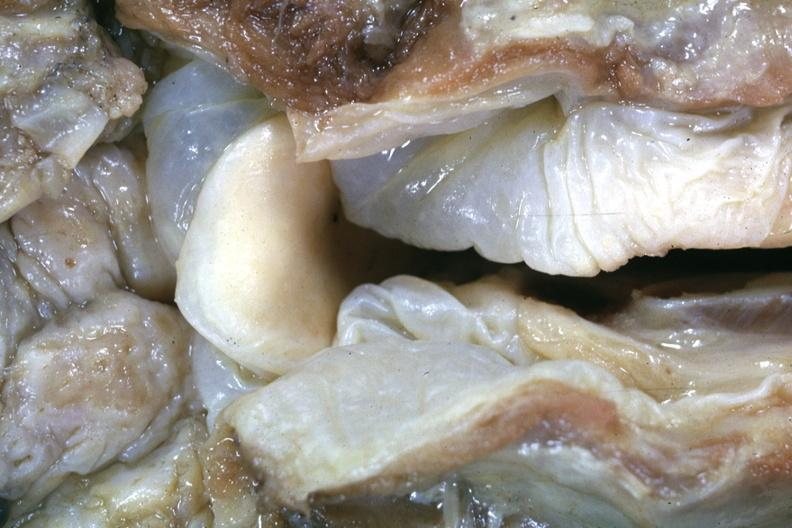how is this a very example of a lesion seldom seen at autopsy slide?
Answer the question using a single word or phrase. Good 